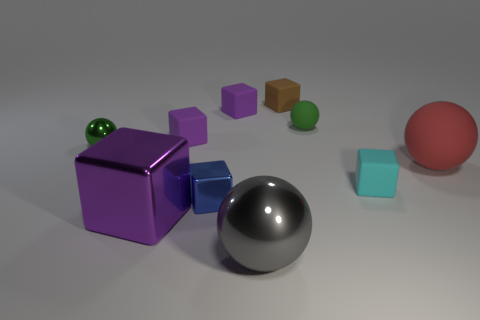Subtract all red cylinders. How many purple cubes are left? 3 Subtract 3 cubes. How many cubes are left? 3 Subtract all tiny cyan blocks. How many blocks are left? 5 Subtract all cyan cubes. How many cubes are left? 5 Subtract all brown cubes. Subtract all purple spheres. How many cubes are left? 5 Subtract all cubes. How many objects are left? 4 Add 7 large rubber objects. How many large rubber objects are left? 8 Add 7 cyan matte things. How many cyan matte things exist? 8 Subtract 0 yellow blocks. How many objects are left? 10 Subtract all big gray rubber spheres. Subtract all small green matte objects. How many objects are left? 9 